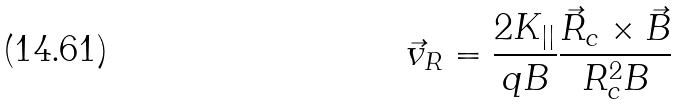Convert formula to latex. <formula><loc_0><loc_0><loc_500><loc_500>\vec { v } _ { R } = \frac { 2 K _ { | | } } { q B } \frac { \vec { R } _ { c } \times \vec { B } } { R _ { c } ^ { 2 } B }</formula> 